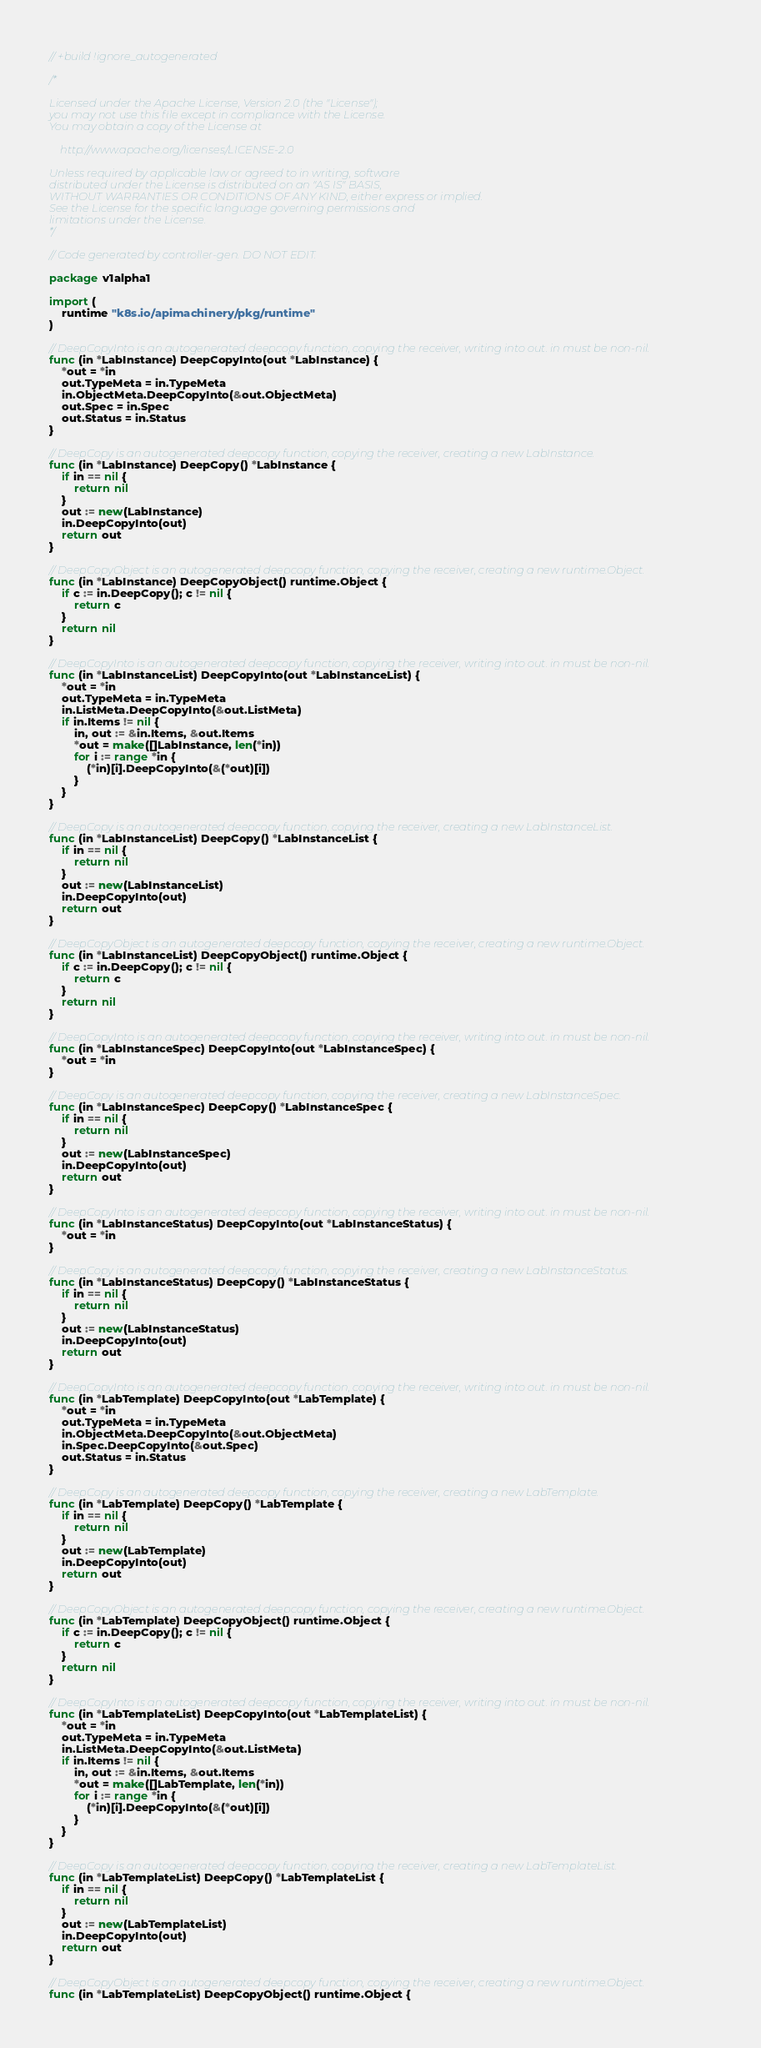<code> <loc_0><loc_0><loc_500><loc_500><_Go_>// +build !ignore_autogenerated

/*

Licensed under the Apache License, Version 2.0 (the "License");
you may not use this file except in compliance with the License.
You may obtain a copy of the License at

    http://www.apache.org/licenses/LICENSE-2.0

Unless required by applicable law or agreed to in writing, software
distributed under the License is distributed on an "AS IS" BASIS,
WITHOUT WARRANTIES OR CONDITIONS OF ANY KIND, either express or implied.
See the License for the specific language governing permissions and
limitations under the License.
*/

// Code generated by controller-gen. DO NOT EDIT.

package v1alpha1

import (
	runtime "k8s.io/apimachinery/pkg/runtime"
)

// DeepCopyInto is an autogenerated deepcopy function, copying the receiver, writing into out. in must be non-nil.
func (in *LabInstance) DeepCopyInto(out *LabInstance) {
	*out = *in
	out.TypeMeta = in.TypeMeta
	in.ObjectMeta.DeepCopyInto(&out.ObjectMeta)
	out.Spec = in.Spec
	out.Status = in.Status
}

// DeepCopy is an autogenerated deepcopy function, copying the receiver, creating a new LabInstance.
func (in *LabInstance) DeepCopy() *LabInstance {
	if in == nil {
		return nil
	}
	out := new(LabInstance)
	in.DeepCopyInto(out)
	return out
}

// DeepCopyObject is an autogenerated deepcopy function, copying the receiver, creating a new runtime.Object.
func (in *LabInstance) DeepCopyObject() runtime.Object {
	if c := in.DeepCopy(); c != nil {
		return c
	}
	return nil
}

// DeepCopyInto is an autogenerated deepcopy function, copying the receiver, writing into out. in must be non-nil.
func (in *LabInstanceList) DeepCopyInto(out *LabInstanceList) {
	*out = *in
	out.TypeMeta = in.TypeMeta
	in.ListMeta.DeepCopyInto(&out.ListMeta)
	if in.Items != nil {
		in, out := &in.Items, &out.Items
		*out = make([]LabInstance, len(*in))
		for i := range *in {
			(*in)[i].DeepCopyInto(&(*out)[i])
		}
	}
}

// DeepCopy is an autogenerated deepcopy function, copying the receiver, creating a new LabInstanceList.
func (in *LabInstanceList) DeepCopy() *LabInstanceList {
	if in == nil {
		return nil
	}
	out := new(LabInstanceList)
	in.DeepCopyInto(out)
	return out
}

// DeepCopyObject is an autogenerated deepcopy function, copying the receiver, creating a new runtime.Object.
func (in *LabInstanceList) DeepCopyObject() runtime.Object {
	if c := in.DeepCopy(); c != nil {
		return c
	}
	return nil
}

// DeepCopyInto is an autogenerated deepcopy function, copying the receiver, writing into out. in must be non-nil.
func (in *LabInstanceSpec) DeepCopyInto(out *LabInstanceSpec) {
	*out = *in
}

// DeepCopy is an autogenerated deepcopy function, copying the receiver, creating a new LabInstanceSpec.
func (in *LabInstanceSpec) DeepCopy() *LabInstanceSpec {
	if in == nil {
		return nil
	}
	out := new(LabInstanceSpec)
	in.DeepCopyInto(out)
	return out
}

// DeepCopyInto is an autogenerated deepcopy function, copying the receiver, writing into out. in must be non-nil.
func (in *LabInstanceStatus) DeepCopyInto(out *LabInstanceStatus) {
	*out = *in
}

// DeepCopy is an autogenerated deepcopy function, copying the receiver, creating a new LabInstanceStatus.
func (in *LabInstanceStatus) DeepCopy() *LabInstanceStatus {
	if in == nil {
		return nil
	}
	out := new(LabInstanceStatus)
	in.DeepCopyInto(out)
	return out
}

// DeepCopyInto is an autogenerated deepcopy function, copying the receiver, writing into out. in must be non-nil.
func (in *LabTemplate) DeepCopyInto(out *LabTemplate) {
	*out = *in
	out.TypeMeta = in.TypeMeta
	in.ObjectMeta.DeepCopyInto(&out.ObjectMeta)
	in.Spec.DeepCopyInto(&out.Spec)
	out.Status = in.Status
}

// DeepCopy is an autogenerated deepcopy function, copying the receiver, creating a new LabTemplate.
func (in *LabTemplate) DeepCopy() *LabTemplate {
	if in == nil {
		return nil
	}
	out := new(LabTemplate)
	in.DeepCopyInto(out)
	return out
}

// DeepCopyObject is an autogenerated deepcopy function, copying the receiver, creating a new runtime.Object.
func (in *LabTemplate) DeepCopyObject() runtime.Object {
	if c := in.DeepCopy(); c != nil {
		return c
	}
	return nil
}

// DeepCopyInto is an autogenerated deepcopy function, copying the receiver, writing into out. in must be non-nil.
func (in *LabTemplateList) DeepCopyInto(out *LabTemplateList) {
	*out = *in
	out.TypeMeta = in.TypeMeta
	in.ListMeta.DeepCopyInto(&out.ListMeta)
	if in.Items != nil {
		in, out := &in.Items, &out.Items
		*out = make([]LabTemplate, len(*in))
		for i := range *in {
			(*in)[i].DeepCopyInto(&(*out)[i])
		}
	}
}

// DeepCopy is an autogenerated deepcopy function, copying the receiver, creating a new LabTemplateList.
func (in *LabTemplateList) DeepCopy() *LabTemplateList {
	if in == nil {
		return nil
	}
	out := new(LabTemplateList)
	in.DeepCopyInto(out)
	return out
}

// DeepCopyObject is an autogenerated deepcopy function, copying the receiver, creating a new runtime.Object.
func (in *LabTemplateList) DeepCopyObject() runtime.Object {</code> 